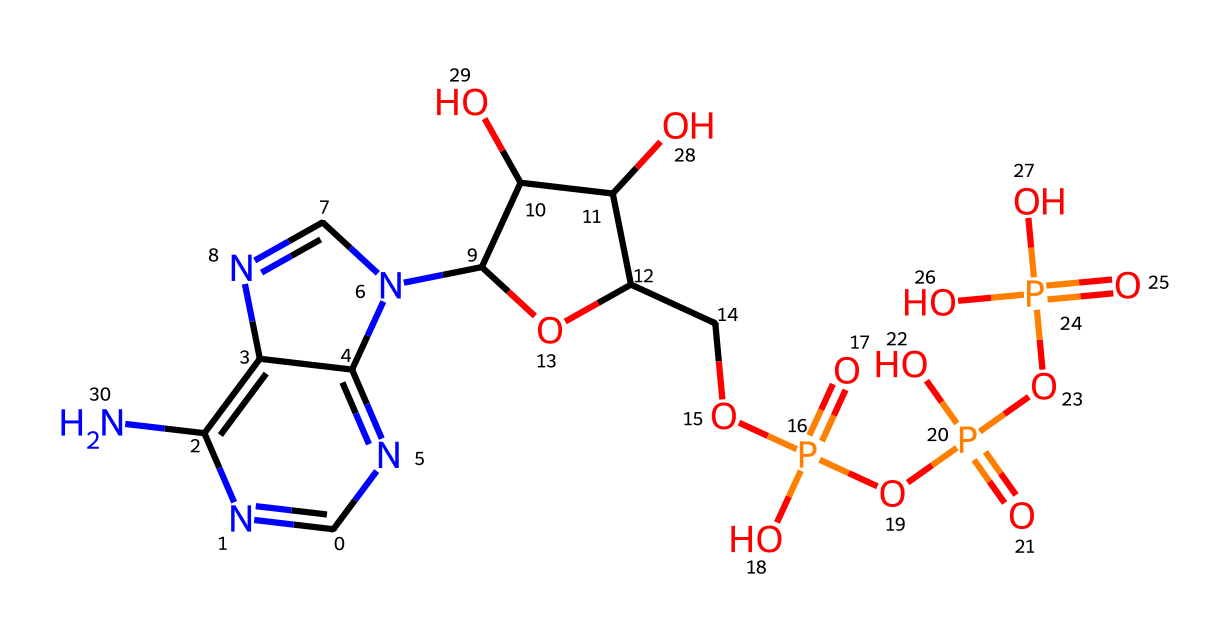How many phosphorus atoms are present in this chemical structure? By inspecting the SMILES representation, we can identify the presence of the phosphorus atom in the three phosphate groups indicated by "P(=O)(O)". Counting these, we see there are three instances of phosphorus involved in the structure.
Answer: 3 What is the total number of oxygen atoms in this compound? Looking at the SMILES, we see multiple instances of "O" present. Each phosphate group contributes four oxygen atoms in total (three from "P(=O)(O)" and one from "O"). Given three phosphate groups, the sum is 12 oxygen atoms.
Answer: 12 What is the primary function of adenosine triphosphate (ATP) in cells? The chemical adenosine triphosphate (ATP) is primarily known as the energy currency of cells, responsible for storing and transferring energy necessary for cellular functions.
Answer: energy currency How many nitrogen atoms are there in this molecule? In the SMILES structure, we can see several "N" notations. Upon counting all the nitrogen atoms present in the representation, we determine that there are six nitrogen atoms.
Answer: 6 Which part of the molecule is crucial for energy release? The three phosphate groups, specifically the high-energy bonds between them, are crucial for energy release during hydrolysis. These bonds can be broken to release energy for various cellular processes.
Answer: phosphate groups What kind of chemical bonding is primarily responsible for the energy stored in ATP? The high-energy bonds, particularly phosphoanhydride bonds between the phosphate groups, are critical as they store energy. Breaking these bonds releases the stored energy needed for cellular activities.
Answer: phosphoanhydride bonds 